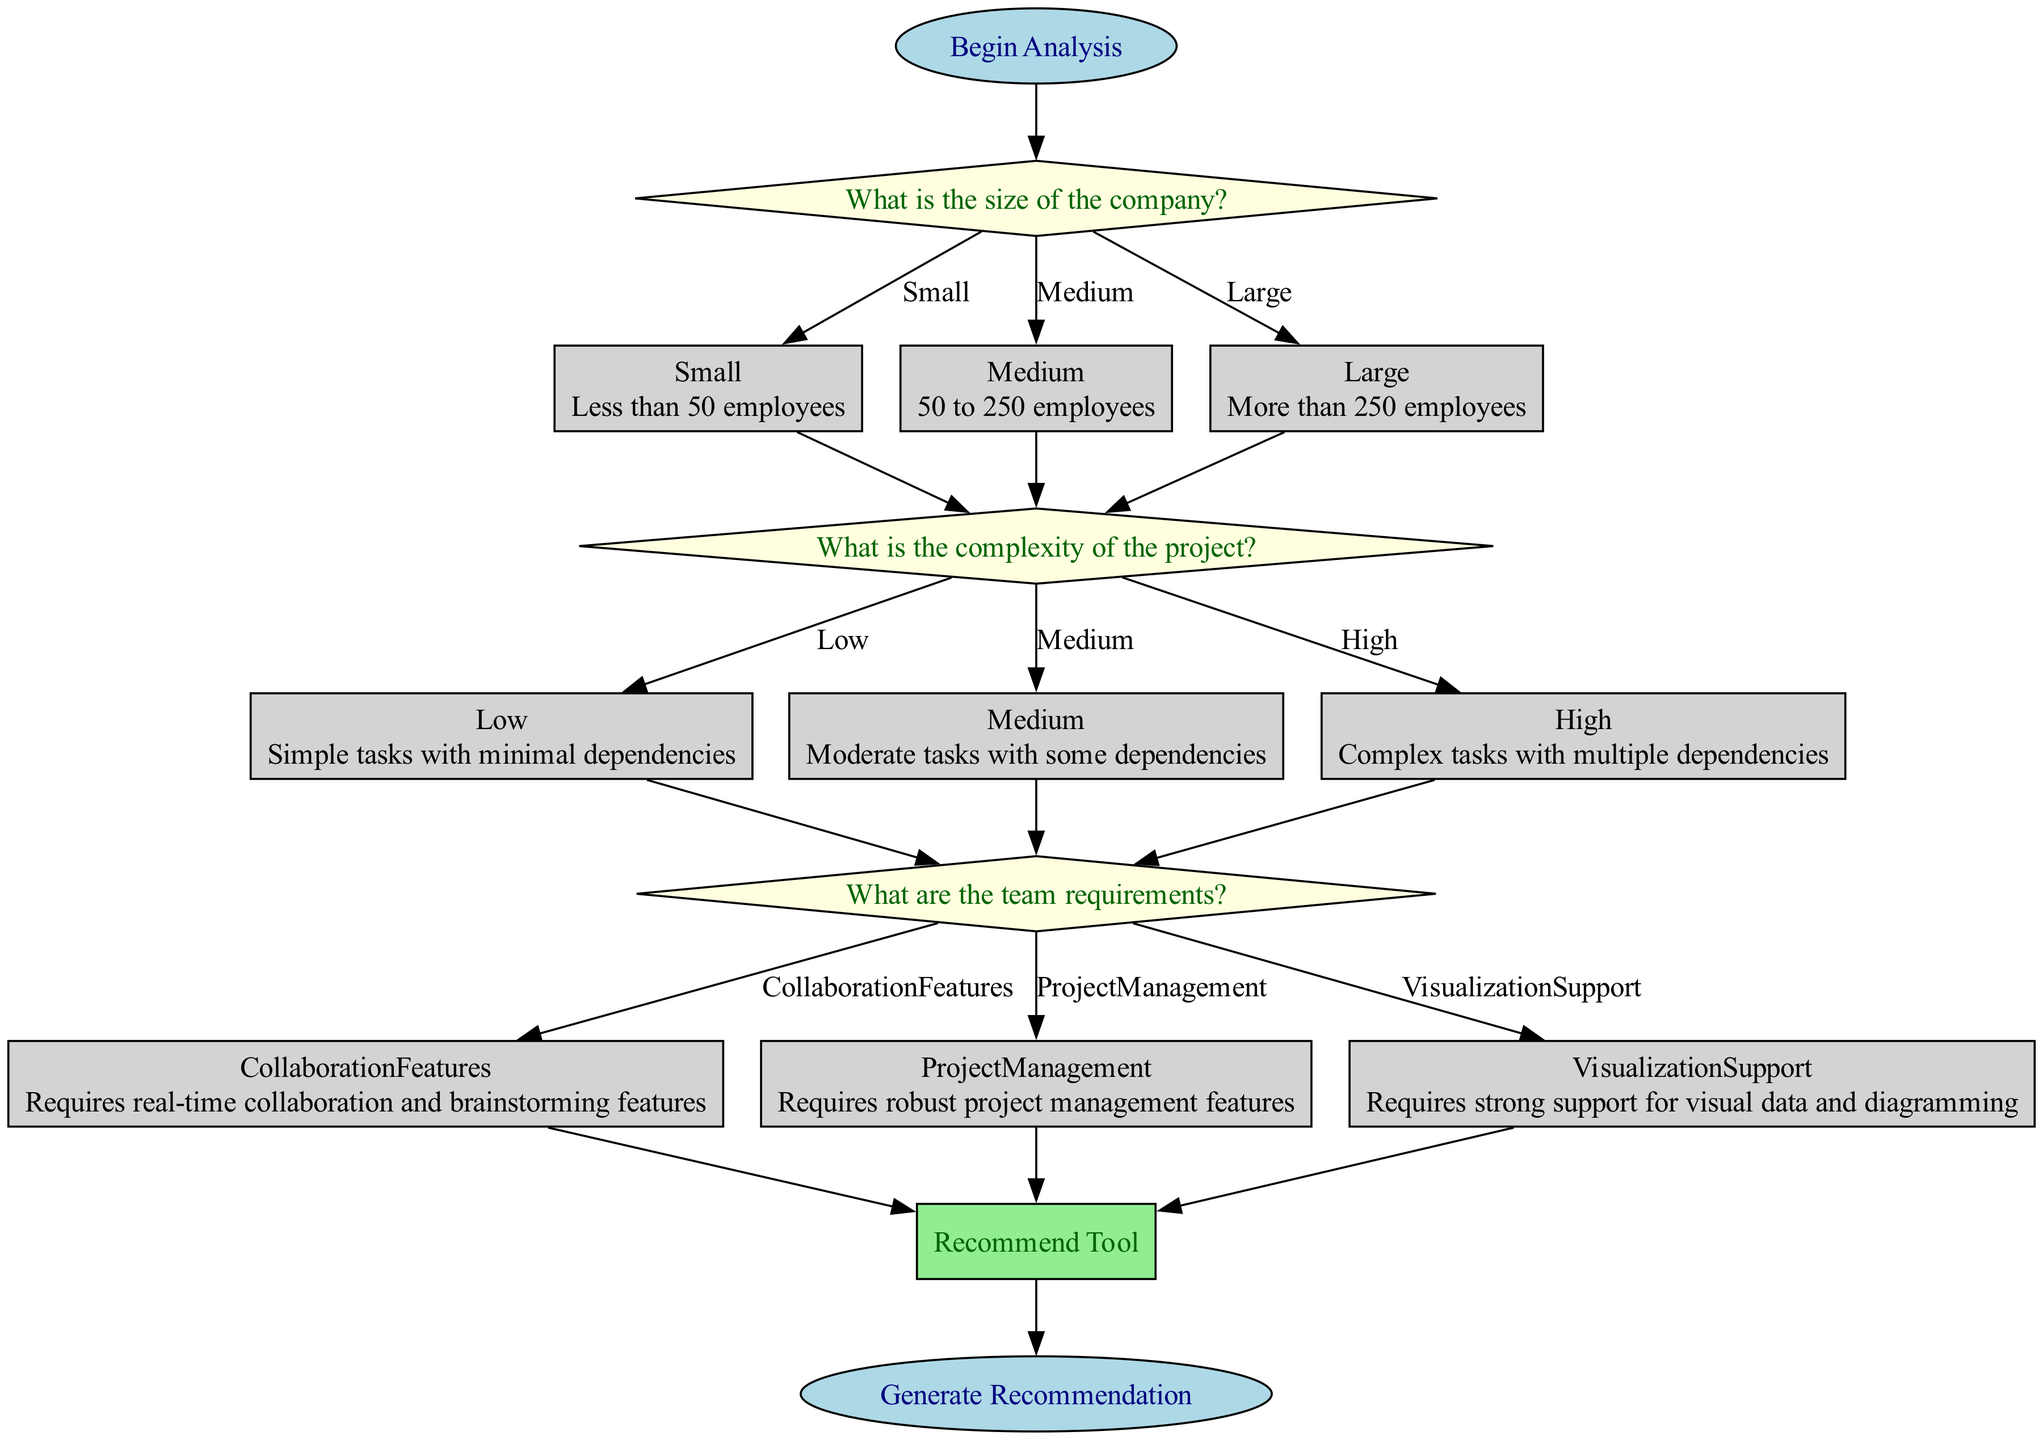What is the first step in the flowchart? The first step is labeled "Begin Analysis," which serves as the starting point of the flowchart. Therefore, the flowchart initiates its process with this specific instruction.
Answer: Begin Analysis How many main decision nodes are present in the diagram? The diagram contains three main decision nodes: "Company Size," "Project Complexity," and "Team Requirements." Each of these nodes asks a critical question guiding the decision-making process.
Answer: Three In the flowchart, what tool is recommended for a small-sized company with low project complexity and a need for collaboration features? According to the flowchart's recommendation section, if a small company has low project complexity and requires collaboration features, the recommended tool is "Miro."
Answer: Miro What is the relationship between "Project Complexity" and "Team Requirements"? "Project Complexity" is a decision node that leads to "Team Requirements." After determining the complexity of a project, the next step is to assess what team requirements are necessary, establishing a direct dependency between these two nodes.
Answer: Leads to What would be the recommended tool for a medium-sized company that requires robust project management features and has medium project complexity? The flowchart specifies that for a medium-sized company with medium project complexity and a need for robust project management features, the recommended tool is "Wrike." Thus, combining the parameters leads to this specific choice.
Answer: Wrike Which team requirement option leads to the recommendation of "Creately"? "Creately" is recommended if the team requires strong support for visual data and diagramming, specifically when the company's size is small and the project's complexity is high. The relevance here is the combination of these specific conditions.
Answer: Visualization Support What tool is recommended for a large-sized company that needs project management features with low project complexity? For a large company that has low project complexity and requires project management features, the flowchart indicates that "Smartsheet" is the recommended tool. Thus, this combination of attributes directly points to "Smartsheet" as the appropriate choice.
Answer: Smartsheet What is the final result after going through the flowchart? The final result of the flowchart is the output labeled "Generate Recommendation," which signifies the completion of the decision-making pathway and the provision of a tool recommendation based on the previous assessments.
Answer: Generate Recommendation What is the next step after identifying the size of the company as "Large"? After identifying the size of the company as "Large," the next step is to "Identify Project Complexity." This decision is essential as it influences subsequent recommendations based on the established size classification.
Answer: Identify Project Complexity 